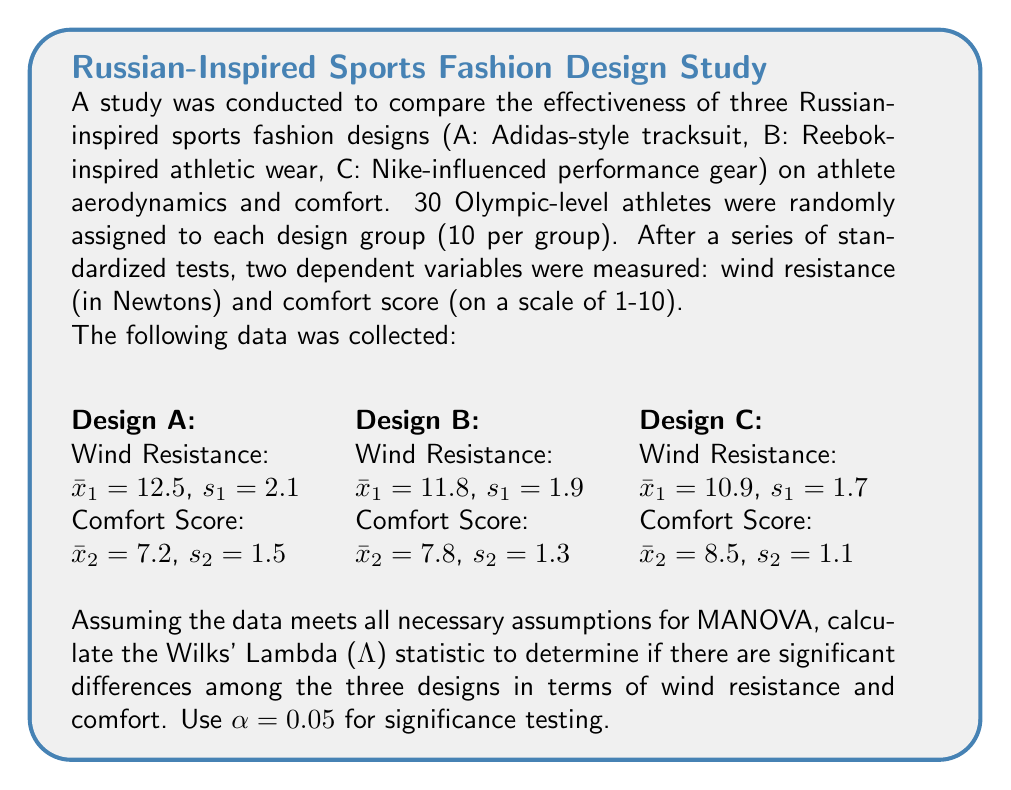Could you help me with this problem? To solve this problem using MANOVA and calculate Wilks' Lambda, we'll follow these steps:

1. Calculate the within-group sum of squares and cross-products matrix (W)
2. Calculate the between-group sum of squares and cross-products matrix (B)
3. Calculate Wilks' Lambda (Λ)
4. Determine the critical value and make a decision

Step 1: Calculate W
For simplicity, we'll use the pooled variance-covariance matrix as an approximation of W:

$$W = (n_1 - 1)S_1 + (n_2 - 1)S_2 + (n_3 - 1)S_3$$

Where $S_i$ is the sample covariance matrix for each group.

$$S_1 = \begin{bmatrix} 2.1^2 & 0 \\ 0 & 1.5^2 \end{bmatrix}, S_2 = \begin{bmatrix} 1.9^2 & 0 \\ 0 & 1.3^2 \end{bmatrix}, S_3 = \begin{bmatrix} 1.7^2 & 0 \\ 0 & 1.1^2 \end{bmatrix}$$

$$W = 9\begin{bmatrix} 4.41 & 0 \\ 0 & 2.25 \end{bmatrix} + 9\begin{bmatrix} 3.61 & 0 \\ 0 & 1.69 \end{bmatrix} + 9\begin{bmatrix} 2.89 & 0 \\ 0 & 1.21 \end{bmatrix}$$

$$W = \begin{bmatrix} 98.19 & 0 \\ 0 & 46.35 \end{bmatrix}$$

Step 2: Calculate B
$$B = \sum_{i=1}^{3} n_i(\bar{x}_i - \bar{x})(\bar{x}_i - \bar{x})'$$

Where $\bar{x}$ is the grand mean vector.

$$\bar{x} = \begin{bmatrix} (12.5 + 11.8 + 10.9)/3 \\ (7.2 + 7.8 + 8.5)/3 \end{bmatrix} = \begin{bmatrix} 11.73 \\ 7.83 \end{bmatrix}$$

$$B = 10\begin{bmatrix} 0.77 \\ -0.63 \end{bmatrix}\begin{bmatrix} 0.77 & -0.63 \end{bmatrix} + 10\begin{bmatrix} 0.07 \\ -0.03 \end{bmatrix}\begin{bmatrix} 0.07 & -0.03 \end{bmatrix} + 10\begin{bmatrix} -0.83 \\ 0.67 \end{bmatrix}\begin{bmatrix} -0.83 & 0.67 \end{bmatrix}$$

$$B = \begin{bmatrix} 13.37 & -10.15 \\ -10.15 & 8.67 \end{bmatrix}$$

Step 3: Calculate Wilks' Lambda (Λ)
$$\Lambda = \frac{|W|}{|W + B|}$$

$$|W| = 98.19 \times 46.35 = 4551.11$$
$$|W + B| = \begin{vmatrix} 111.56 & -10.15 \\ -10.15 & 55.02 \end{vmatrix} = 6079.34$$

$$\Lambda = \frac{4551.11}{6079.34} = 0.7486$$

Step 4: Determine critical value and make decision
For α = 0.05, p = 2 (dependent variables), g = 3 (groups), n = 30 (total sample size):
Degrees of freedom: df1 = p(g-1) = 2(3-1) = 4, df2 = 2(n-g-1) = 2(30-3-1) = 52

The critical value for Wilks' Lambda with these parameters is approximately 0.7799.

Since our calculated Λ (0.7486) is less than the critical value (0.7799), we reject the null hypothesis.
Answer: Wilks' Lambda = 0.7486; significant differences exist among designs (p < 0.05) 